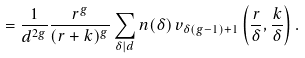<formula> <loc_0><loc_0><loc_500><loc_500>= \frac { 1 } { d ^ { 2 g } } \frac { r ^ { g } } { ( r + k ) ^ { g } } \sum _ { \delta | d } n ( { \delta } ) \, v _ { { \delta } ( g - 1 ) + 1 } \left ( \frac { r } { \delta } , \frac { k } { \delta } \right ) .</formula> 